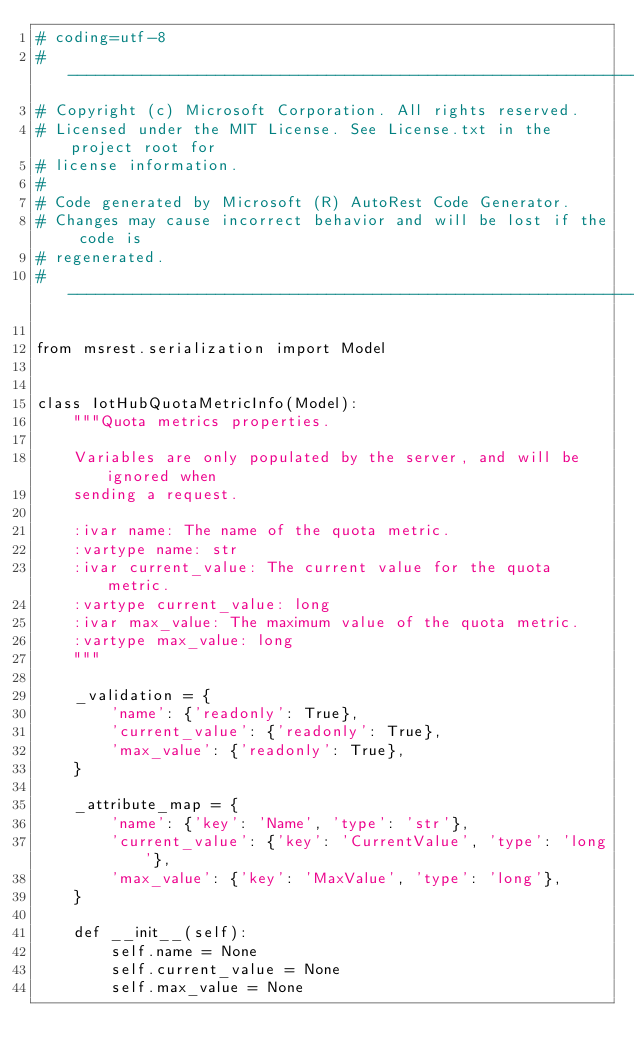Convert code to text. <code><loc_0><loc_0><loc_500><loc_500><_Python_># coding=utf-8
# --------------------------------------------------------------------------
# Copyright (c) Microsoft Corporation. All rights reserved.
# Licensed under the MIT License. See License.txt in the project root for
# license information.
#
# Code generated by Microsoft (R) AutoRest Code Generator.
# Changes may cause incorrect behavior and will be lost if the code is
# regenerated.
# --------------------------------------------------------------------------

from msrest.serialization import Model


class IotHubQuotaMetricInfo(Model):
    """Quota metrics properties.

    Variables are only populated by the server, and will be ignored when
    sending a request.

    :ivar name: The name of the quota metric.
    :vartype name: str
    :ivar current_value: The current value for the quota metric.
    :vartype current_value: long
    :ivar max_value: The maximum value of the quota metric.
    :vartype max_value: long
    """

    _validation = {
        'name': {'readonly': True},
        'current_value': {'readonly': True},
        'max_value': {'readonly': True},
    }

    _attribute_map = {
        'name': {'key': 'Name', 'type': 'str'},
        'current_value': {'key': 'CurrentValue', 'type': 'long'},
        'max_value': {'key': 'MaxValue', 'type': 'long'},
    }

    def __init__(self):
        self.name = None
        self.current_value = None
        self.max_value = None
</code> 